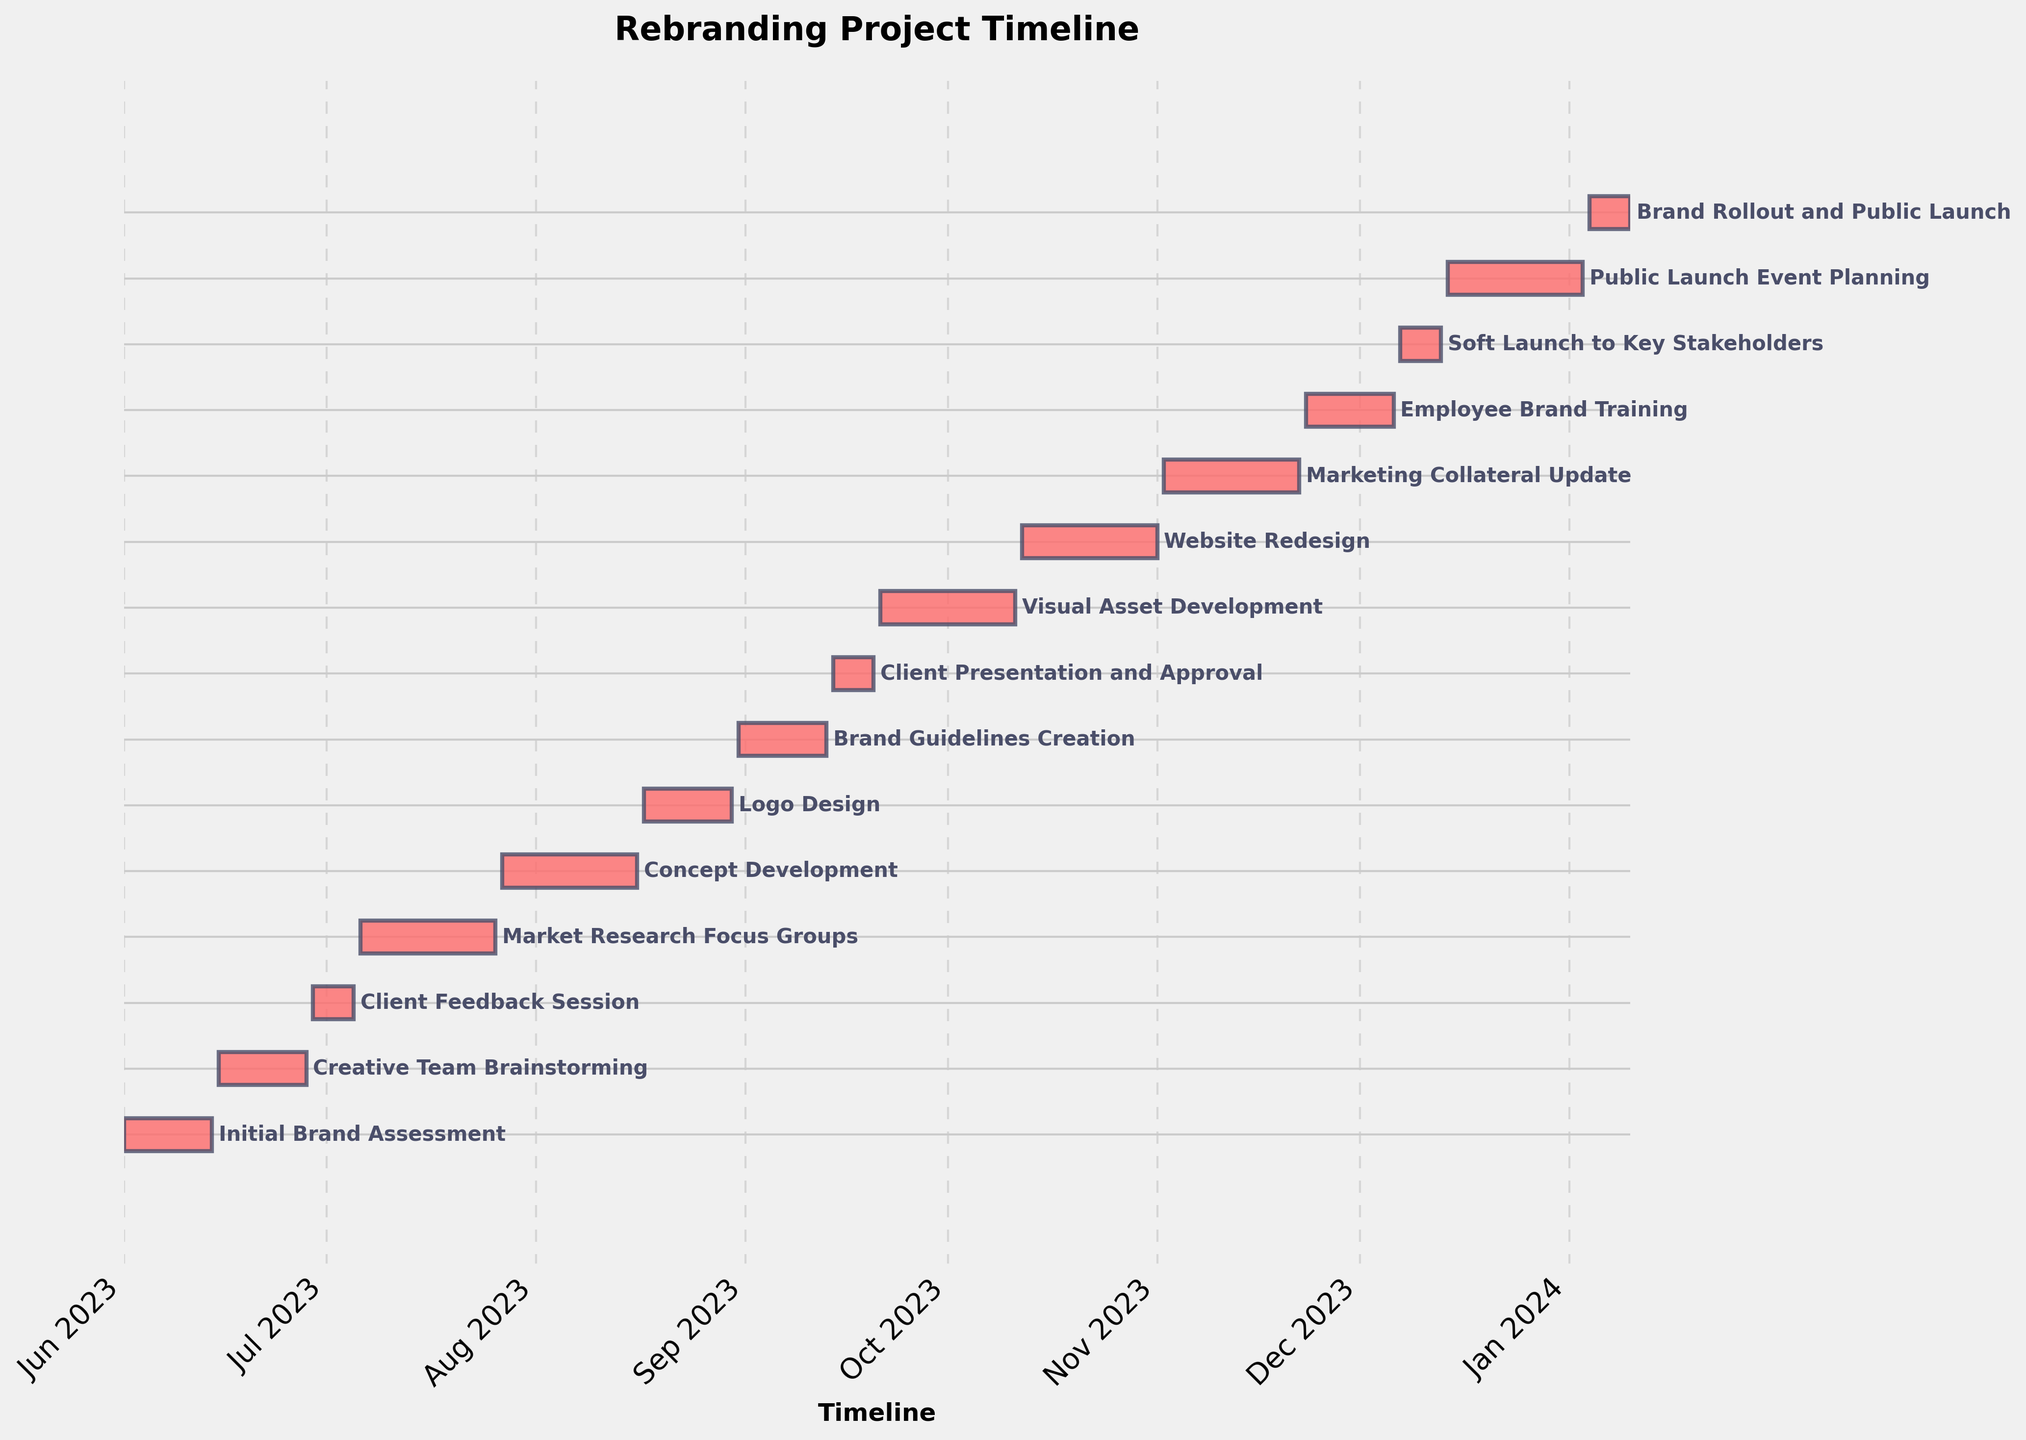What's the title of the Gantt chart? The title is usually displayed at the top of the chart and summarizes its content. In this case, it indicates the focus of the Gantt chart, which is the rebranding project timeline.
Answer: Rebranding Project Timeline When does the first task, 'Initial Brand Assessment,' start and end? You can find the start and end dates of 'Initial Brand Assessment' by locating its corresponding bar on the chart. The bar's left edge represents the start date, and the right edge represents the end date.
Answer: Starts on 2023-06-01 and ends on 2023-06-14 How long does the 'Logo Design' task take? The duration of a task can be calculated by measuring the length of its bar and converting it to days. 'Logo Design' starts on 2023-08-17 and ends on 2023-08-30, so you subtract the start date from the end date to get the duration.
Answer: 14 days Which task immediately follows 'Market Research Focus Groups'? By examining the timeline, you can see which bar starts immediately after the 'Market Research Focus Groups' bar ends. 'Concept Development' starts right after it.
Answer: Concept Development How long is the gap between 'Client Feedback Session' and 'Market Research Focus Groups'? To find the gap between two tasks, you look at the end date of the first task and the start date of the second task, then calculate the difference in days. 'Client Feedback Session' ends on 2023-07-05, 'Market Research Focus Groups' starts on 2023-07-06, so the gap is one day.
Answer: 1 day What is the duration of the entire project from start to finish? The overall project duration is calculated from the start date of the first task to the end date of the last task. 'Initial Brand Assessment' starts on 2023-06-01 and 'Brand Rollout and Public Launch' ends on 2024-01-10.
Answer: About 224 days Which stage takes the longest time to complete? To determine the longest stage, you check the duration of each task by looking at the length of the bars and identifying the longest one. 'Market Research Focus Groups' have the longest bar, indicating the longest duration.
Answer: Market Research Focus Groups Are there any tasks that overlap with 'Website Redesign'? If yes, which ones? To identify overlapping tasks, you compare the start and end dates of 'Website Redesign' with other tasks. Tasks that have dates within this range are overlapping. 'Visual Asset Development' and 'Marketing Collateral Update' overlap with 'Website Redesign'.
Answer: Visual Asset Development, Marketing Collateral Update Which tasks are scheduled during December? By looking at the Gantt chart, you identify which bars fall within the month of December. This involves finding tasks whose start or end dates include December. 'Employee Brand Training,' 'Soft Launch to Key Stakeholders,' 'Public Launch Event Planning,' and 'Brand Rollout and Public Launch' are scheduled during December.
Answer: Employee Brand Training, Soft Launch to Key Stakeholders, Public Launch Event Planning, Brand Rollout and Public Launch How much time is there between 'Brand Guidelines Creation' and 'Client Presentation and Approval'? To find the gap between these two tasks, you note the end date of 'Brand Guidelines Creation' and the start date of 'Client Presentation and Approval,' then compute the difference in days. 'Brand Guidelines Creation' ends on 2023-09-13 and 'Client Presentation and Approval' starts on 2023-09-14.
Answer: No gap 